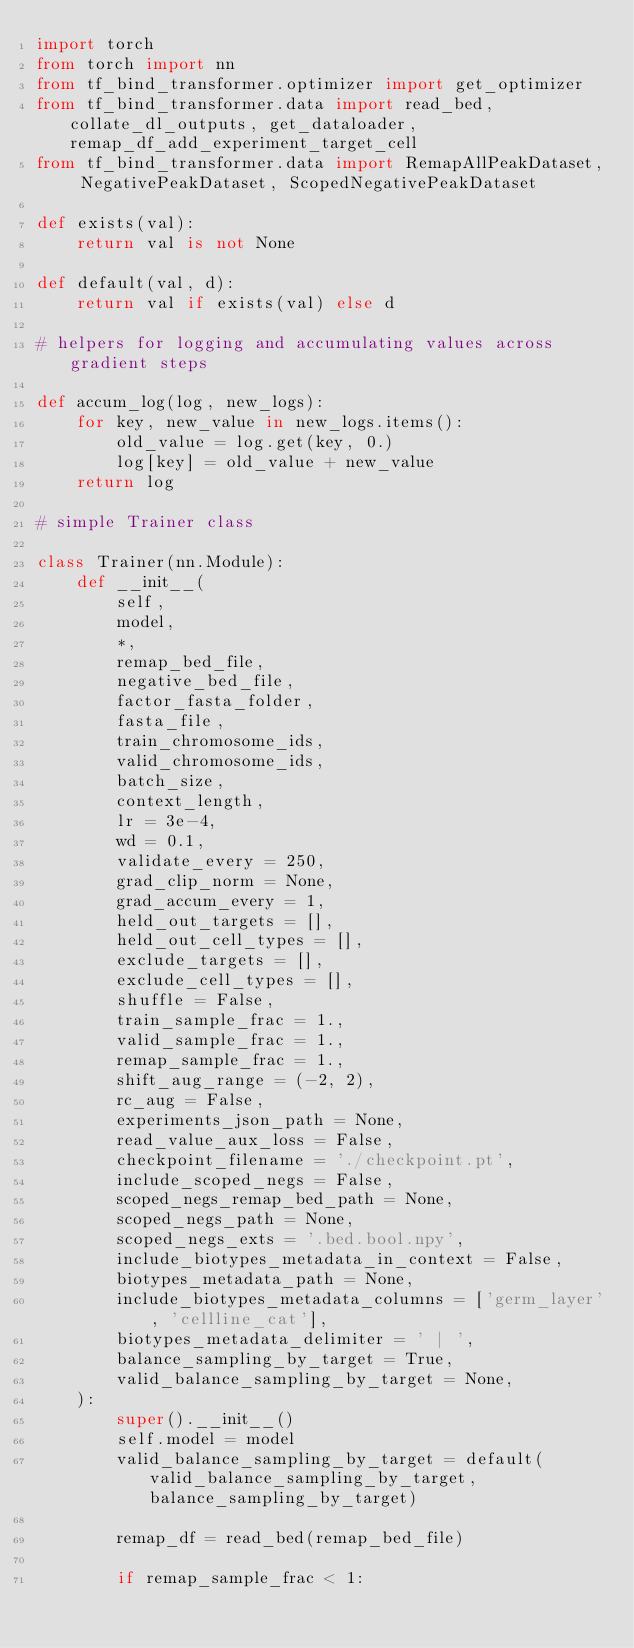Convert code to text. <code><loc_0><loc_0><loc_500><loc_500><_Python_>import torch
from torch import nn
from tf_bind_transformer.optimizer import get_optimizer
from tf_bind_transformer.data import read_bed, collate_dl_outputs, get_dataloader, remap_df_add_experiment_target_cell
from tf_bind_transformer.data import RemapAllPeakDataset, NegativePeakDataset, ScopedNegativePeakDataset

def exists(val):
    return val is not None

def default(val, d):
    return val if exists(val) else d

# helpers for logging and accumulating values across gradient steps

def accum_log(log, new_logs):
    for key, new_value in new_logs.items():
        old_value = log.get(key, 0.)
        log[key] = old_value + new_value
    return log

# simple Trainer class

class Trainer(nn.Module):
    def __init__(
        self,
        model,
        *,
        remap_bed_file,
        negative_bed_file,
        factor_fasta_folder,
        fasta_file,
        train_chromosome_ids,
        valid_chromosome_ids,
        batch_size,
        context_length,
        lr = 3e-4,
        wd = 0.1,
        validate_every = 250,
        grad_clip_norm = None,
        grad_accum_every = 1,
        held_out_targets = [],
        held_out_cell_types = [],
        exclude_targets = [],
        exclude_cell_types = [],
        shuffle = False,
        train_sample_frac = 1.,
        valid_sample_frac = 1.,
        remap_sample_frac = 1.,
        shift_aug_range = (-2, 2),
        rc_aug = False,
        experiments_json_path = None,
        read_value_aux_loss = False,
        checkpoint_filename = './checkpoint.pt',
        include_scoped_negs = False,
        scoped_negs_remap_bed_path = None,
        scoped_negs_path = None,
        scoped_negs_exts = '.bed.bool.npy',
        include_biotypes_metadata_in_context = False,
        biotypes_metadata_path = None,
        include_biotypes_metadata_columns = ['germ_layer', 'cellline_cat'],
        biotypes_metadata_delimiter = ' | ',
        balance_sampling_by_target = True,
        valid_balance_sampling_by_target = None,
    ):
        super().__init__()
        self.model = model
        valid_balance_sampling_by_target = default(valid_balance_sampling_by_target, balance_sampling_by_target)

        remap_df = read_bed(remap_bed_file)

        if remap_sample_frac < 1:</code> 